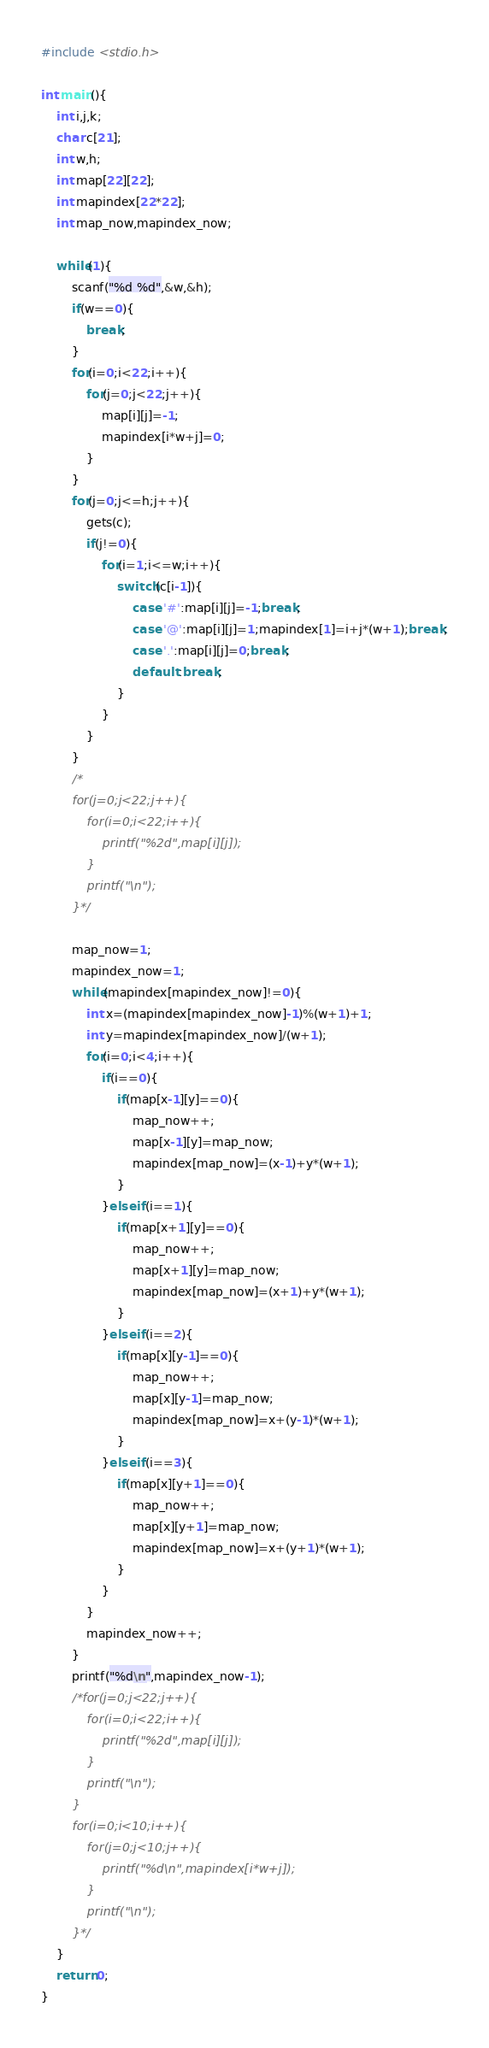Convert code to text. <code><loc_0><loc_0><loc_500><loc_500><_C_>#include <stdio.h>

int main(){
	int i,j,k;
	char c[21];
	int w,h;
	int map[22][22];
	int mapindex[22*22];
	int map_now,mapindex_now;
	
	while(1){
		scanf("%d %d",&w,&h);
		if(w==0){
			break;
		}
		for(i=0;i<22;i++){
			for(j=0;j<22;j++){
				map[i][j]=-1;
				mapindex[i*w+j]=0;
			}
		}
		for(j=0;j<=h;j++){
			gets(c);
			if(j!=0){
				for(i=1;i<=w;i++){
					switch(c[i-1]){
						case '#':map[i][j]=-1;break;
						case '@':map[i][j]=1;mapindex[1]=i+j*(w+1);break;
						case '.':map[i][j]=0;break;
						default :break;
					}
				}
			}
		}
		/*
		for(j=0;j<22;j++){
			for(i=0;i<22;i++){
				printf("%2d",map[i][j]);
			}
			printf("\n");
		}*/
		
		map_now=1;
		mapindex_now=1;
		while(mapindex[mapindex_now]!=0){
			int x=(mapindex[mapindex_now]-1)%(w+1)+1;
			int y=mapindex[mapindex_now]/(w+1);
			for(i=0;i<4;i++){
				if(i==0){
					if(map[x-1][y]==0){
						map_now++;
						map[x-1][y]=map_now;
						mapindex[map_now]=(x-1)+y*(w+1);
					}
				}else if(i==1){
					if(map[x+1][y]==0){
						map_now++;
						map[x+1][y]=map_now;
						mapindex[map_now]=(x+1)+y*(w+1);
					}
				}else if(i==2){
					if(map[x][y-1]==0){
						map_now++;
						map[x][y-1]=map_now;
						mapindex[map_now]=x+(y-1)*(w+1);
					}
				}else if(i==3){
					if(map[x][y+1]==0){
						map_now++;
						map[x][y+1]=map_now;
						mapindex[map_now]=x+(y+1)*(w+1);
					}
				}
			}
			mapindex_now++;
		}
		printf("%d\n",mapindex_now-1);
		/*for(j=0;j<22;j++){
			for(i=0;i<22;i++){
				printf("%2d",map[i][j]);
			}
			printf("\n");
		}
		for(i=0;i<10;i++){
			for(j=0;j<10;j++){
				printf("%d\n",mapindex[i*w+j]);
			}
			printf("\n");
		}*/
	}
	return 0;
}</code> 